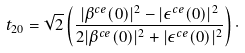<formula> <loc_0><loc_0><loc_500><loc_500>t _ { 2 0 } = \sqrt { 2 } \left ( \frac { | \beta ^ { c e } ( 0 ) | ^ { 2 } - | \epsilon ^ { c e } ( 0 ) | ^ { 2 } } { 2 | \beta ^ { c e } ( 0 ) | ^ { 2 } + | \epsilon ^ { c e } ( 0 ) | ^ { 2 } } \right ) \cdot</formula> 